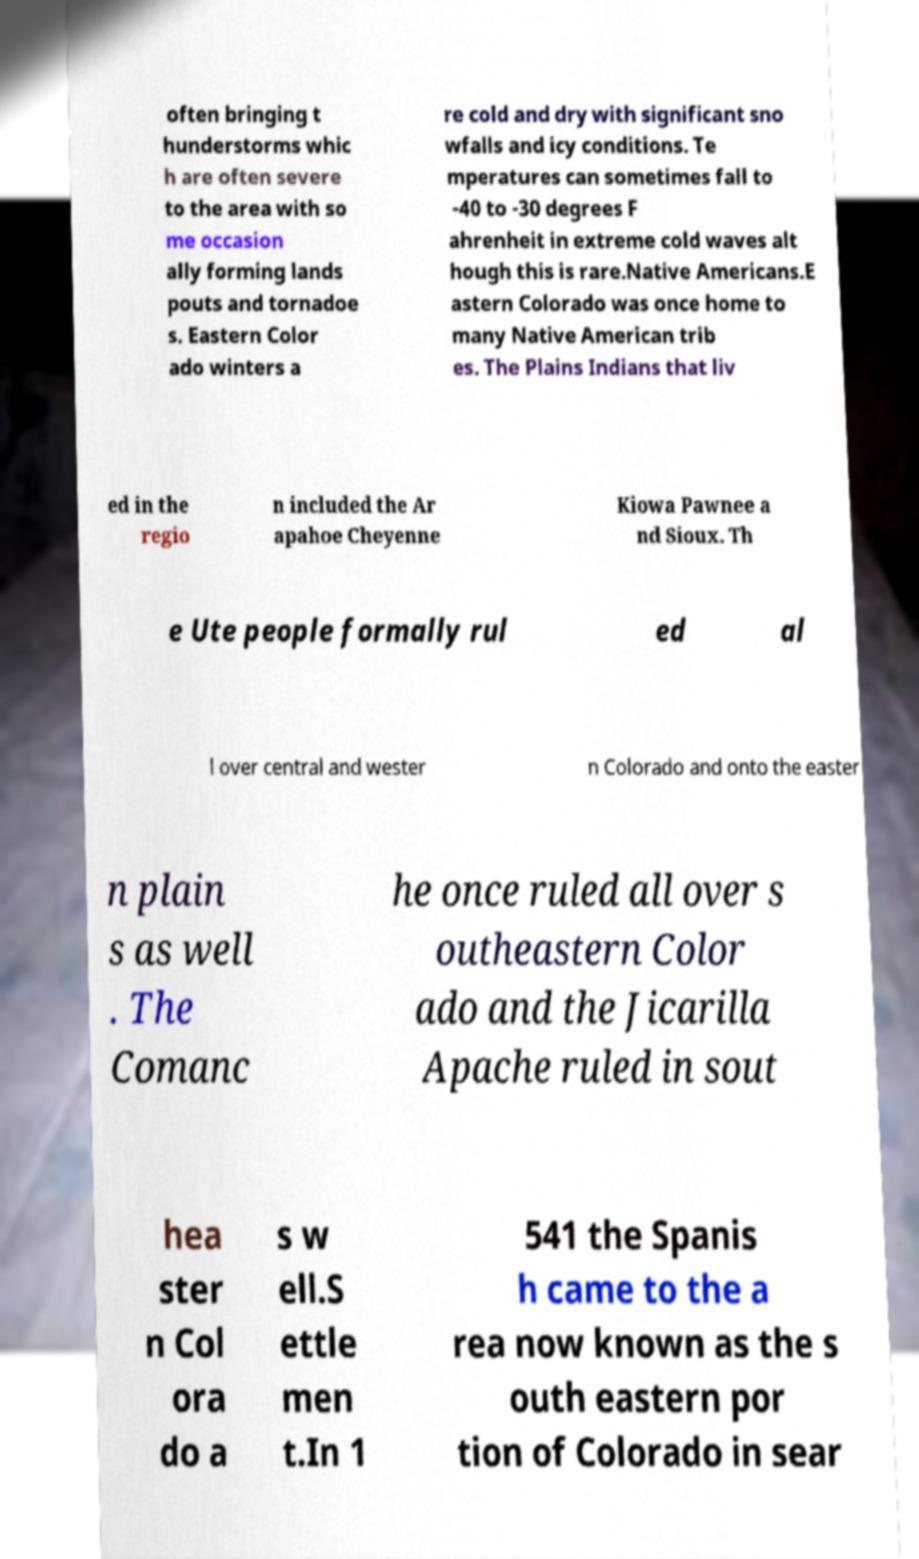Can you read and provide the text displayed in the image?This photo seems to have some interesting text. Can you extract and type it out for me? often bringing t hunderstorms whic h are often severe to the area with so me occasion ally forming lands pouts and tornadoe s. Eastern Color ado winters a re cold and dry with significant sno wfalls and icy conditions. Te mperatures can sometimes fall to -40 to -30 degrees F ahrenheit in extreme cold waves alt hough this is rare.Native Americans.E astern Colorado was once home to many Native American trib es. The Plains Indians that liv ed in the regio n included the Ar apahoe Cheyenne Kiowa Pawnee a nd Sioux. Th e Ute people formally rul ed al l over central and wester n Colorado and onto the easter n plain s as well . The Comanc he once ruled all over s outheastern Color ado and the Jicarilla Apache ruled in sout hea ster n Col ora do a s w ell.S ettle men t.In 1 541 the Spanis h came to the a rea now known as the s outh eastern por tion of Colorado in sear 